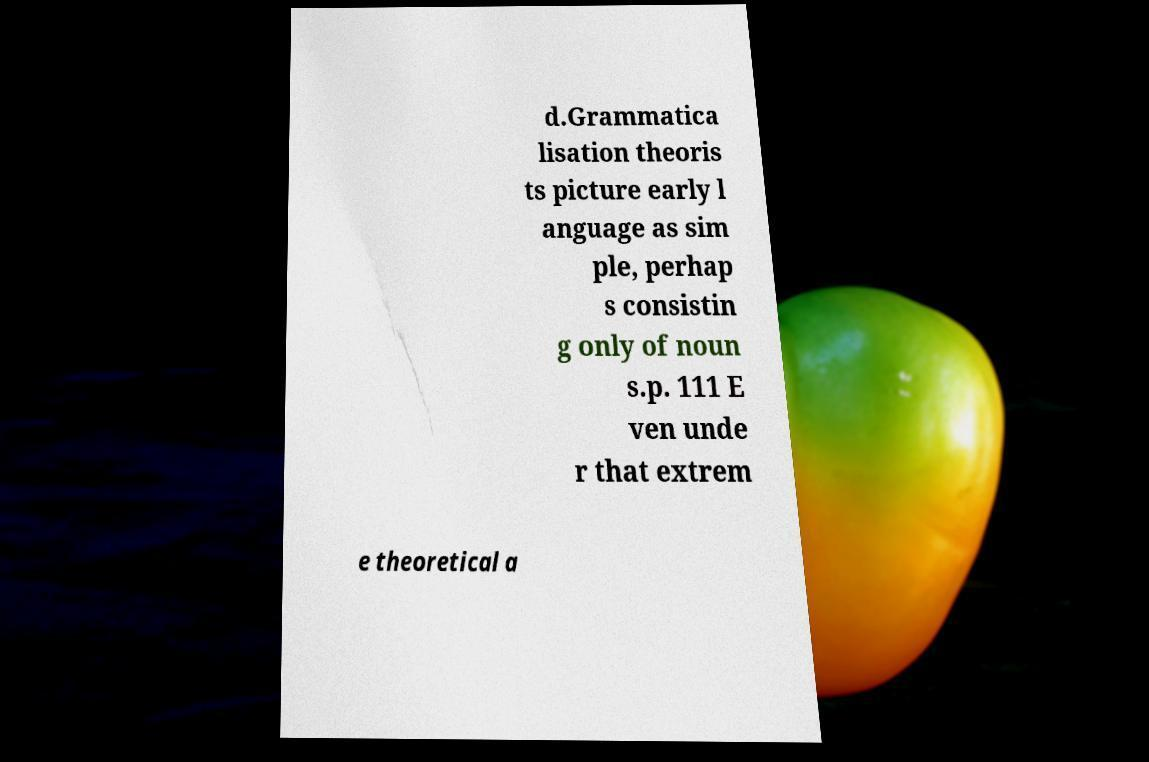Please identify and transcribe the text found in this image. d.Grammatica lisation theoris ts picture early l anguage as sim ple, perhap s consistin g only of noun s.p. 111 E ven unde r that extrem e theoretical a 